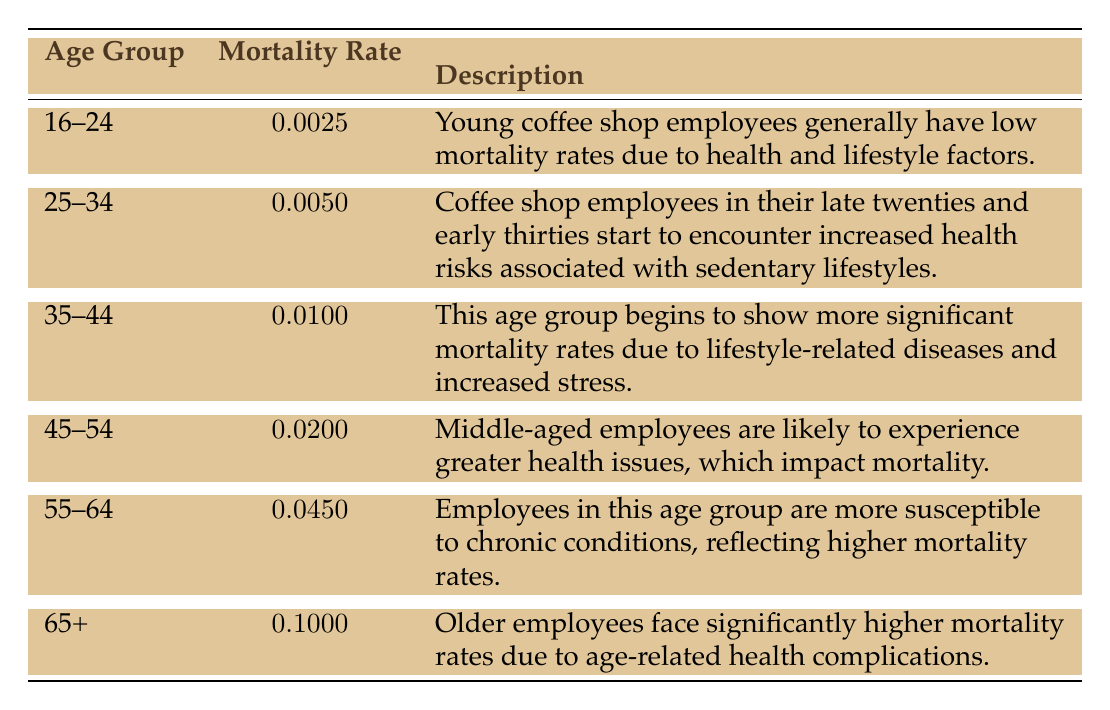What is the mortality rate for coffee shop employees aged 25-34? The table lists the age group of 25-34 with a corresponding mortality rate of 0.0050.
Answer: 0.0050 Which age group shows the highest mortality rate? The table indicates that the age group 65+ has a mortality rate of 0.1000, which is the highest of all the groups listed.
Answer: 65+ Is it true that employees aged 16-24 have higher mortality rates than those aged 35-44? Comparing the mortality rates from the table, 16-24 has a rate of 0.0025, while 35-44 has a rate of 0.0100. Thus, it is false that 16-24 has higher mortality rates.
Answer: No What is the difference in mortality rates between the age groups 45-54 and 55-64? The mortality rate for 45-54 is 0.0200, while for 55-64 it is 0.0450. Subtracting, we find 0.0450 - 0.0200 = 0.0250, showing 55-64 has a higher rate by this amount.
Answer: 0.0250 Are coffee shop employees aged 35-44 more prone to health risks as their age increases? The table indicates that as age increases, the mortality rates do as well; 35-44 has a rate of 0.0100, while 45-54 has a rate of 0.0200, supporting that older employees face greater health risks.
Answer: Yes What is the average mortality rate of the age groups 16-24 and 65+? The rates for 16-24 is 0.0025 and for 65+ is 0.1000. To find the average, add 0.0025 and 0.1000 to get 0.1025, then divide by 2. Thus, the average is 0.1025/2 = 0.05125.
Answer: 0.05125 Do employees aged 55-64 have a mortality rate that reflects greater susceptibility to chronic conditions compared to younger employees? The table shows that 55-64 (0.0450) has a significantly higher mortality rate than younger groups like 16-24 (0.0025), indicating greater susceptibility.
Answer: Yes What is the overall trend in mortality rates as age increases from 16-24 to 65+? The table displays a clear upward trend in mortality rates as the age groups progress from 16-24 (0.0025) to 65+ (0.1000), demonstrating that older age groups face significantly higher mortality risks.
Answer: Increasing trend 